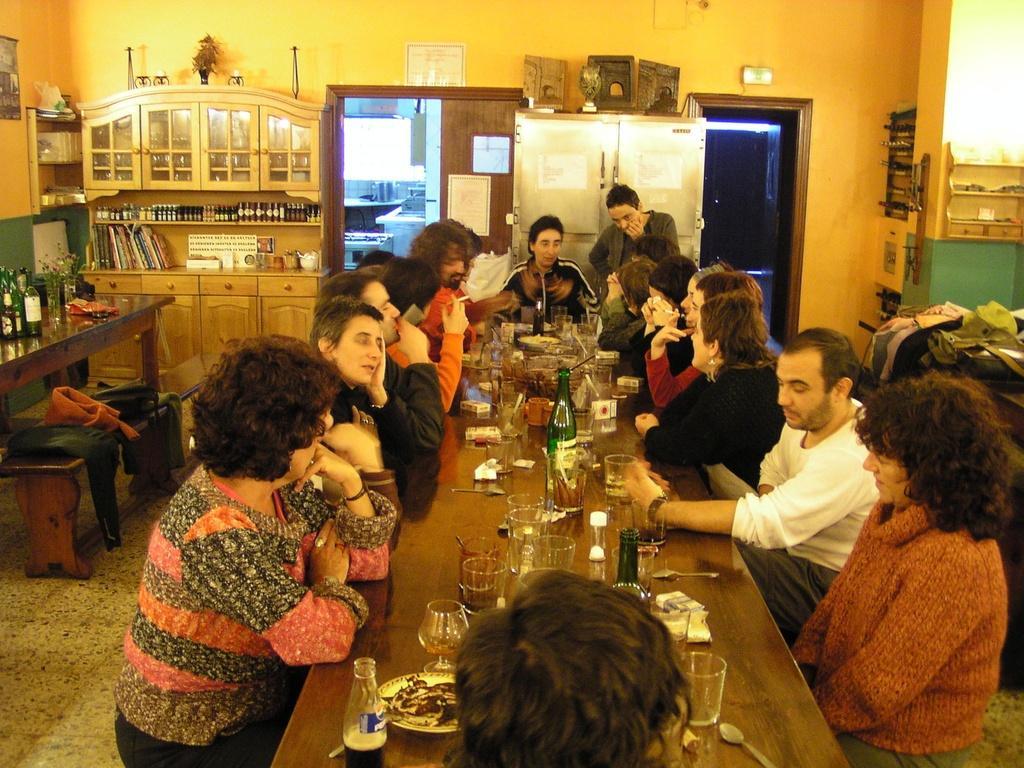Can you describe this image briefly? There are many people sitting over a table. And on the table there are many glasses, bottles , plates and food items. In the background there is a door. There are many bottle on the shelf. books are kept on the shelf. There are drawers for the shelf. Some jackets are kept on the bench. 